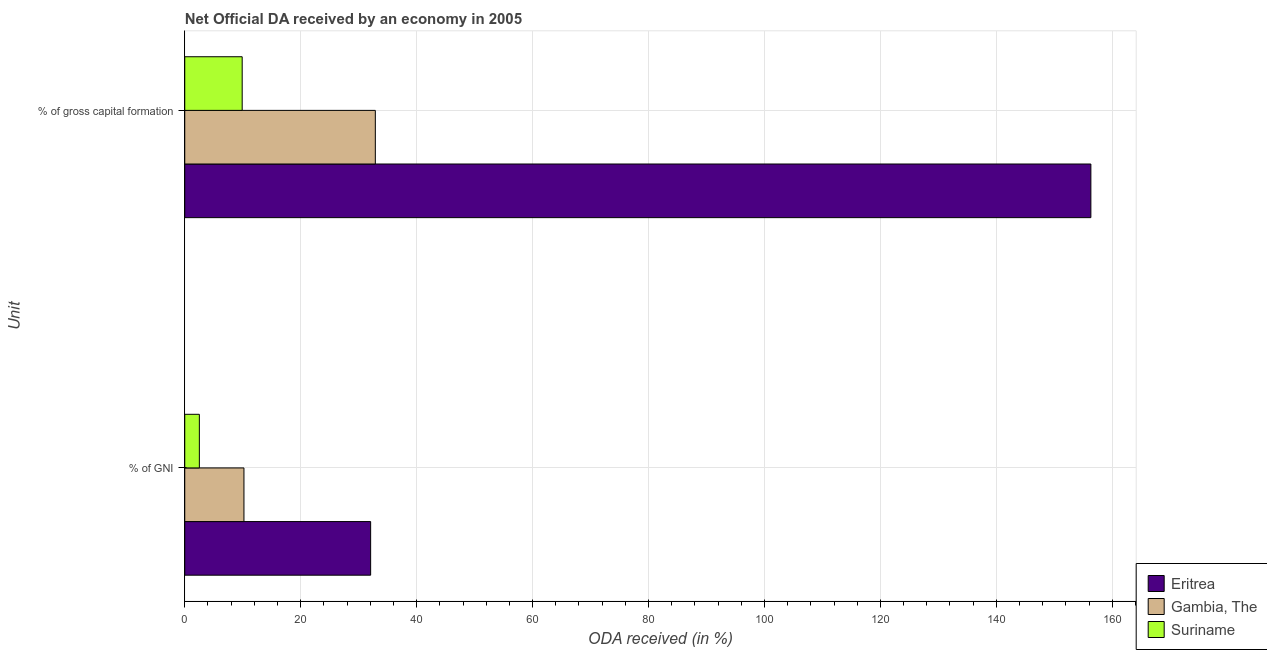How many different coloured bars are there?
Your answer should be compact. 3. How many groups of bars are there?
Ensure brevity in your answer.  2. Are the number of bars per tick equal to the number of legend labels?
Provide a succinct answer. Yes. Are the number of bars on each tick of the Y-axis equal?
Provide a succinct answer. Yes. How many bars are there on the 2nd tick from the top?
Provide a succinct answer. 3. What is the label of the 1st group of bars from the top?
Your answer should be very brief. % of gross capital formation. What is the oda received as percentage of gross capital formation in Eritrea?
Make the answer very short. 156.31. Across all countries, what is the maximum oda received as percentage of gni?
Make the answer very short. 32.07. Across all countries, what is the minimum oda received as percentage of gni?
Make the answer very short. 2.52. In which country was the oda received as percentage of gni maximum?
Provide a succinct answer. Eritrea. In which country was the oda received as percentage of gni minimum?
Your answer should be compact. Suriname. What is the total oda received as percentage of gross capital formation in the graph?
Offer a very short reply. 199.09. What is the difference between the oda received as percentage of gross capital formation in Suriname and that in Eritrea?
Make the answer very short. -146.4. What is the difference between the oda received as percentage of gni in Eritrea and the oda received as percentage of gross capital formation in Gambia, The?
Give a very brief answer. -0.81. What is the average oda received as percentage of gni per country?
Offer a terse response. 14.93. What is the difference between the oda received as percentage of gni and oda received as percentage of gross capital formation in Suriname?
Offer a very short reply. -7.39. What is the ratio of the oda received as percentage of gross capital formation in Suriname to that in Gambia, The?
Offer a terse response. 0.3. Is the oda received as percentage of gni in Gambia, The less than that in Eritrea?
Keep it short and to the point. Yes. In how many countries, is the oda received as percentage of gross capital formation greater than the average oda received as percentage of gross capital formation taken over all countries?
Your response must be concise. 1. What does the 2nd bar from the top in % of GNI represents?
Your response must be concise. Gambia, The. What does the 3rd bar from the bottom in % of GNI represents?
Make the answer very short. Suriname. Are all the bars in the graph horizontal?
Offer a very short reply. Yes. What is the difference between two consecutive major ticks on the X-axis?
Your answer should be compact. 20. Does the graph contain grids?
Provide a short and direct response. Yes. What is the title of the graph?
Offer a very short reply. Net Official DA received by an economy in 2005. Does "Turks and Caicos Islands" appear as one of the legend labels in the graph?
Provide a short and direct response. No. What is the label or title of the X-axis?
Offer a very short reply. ODA received (in %). What is the label or title of the Y-axis?
Provide a short and direct response. Unit. What is the ODA received (in %) in Eritrea in % of GNI?
Provide a short and direct response. 32.07. What is the ODA received (in %) in Gambia, The in % of GNI?
Provide a succinct answer. 10.21. What is the ODA received (in %) of Suriname in % of GNI?
Your answer should be compact. 2.52. What is the ODA received (in %) in Eritrea in % of gross capital formation?
Your answer should be compact. 156.31. What is the ODA received (in %) in Gambia, The in % of gross capital formation?
Keep it short and to the point. 32.87. What is the ODA received (in %) in Suriname in % of gross capital formation?
Give a very brief answer. 9.91. Across all Unit, what is the maximum ODA received (in %) of Eritrea?
Offer a very short reply. 156.31. Across all Unit, what is the maximum ODA received (in %) of Gambia, The?
Offer a very short reply. 32.87. Across all Unit, what is the maximum ODA received (in %) in Suriname?
Make the answer very short. 9.91. Across all Unit, what is the minimum ODA received (in %) in Eritrea?
Your answer should be compact. 32.07. Across all Unit, what is the minimum ODA received (in %) in Gambia, The?
Ensure brevity in your answer.  10.21. Across all Unit, what is the minimum ODA received (in %) of Suriname?
Provide a succinct answer. 2.52. What is the total ODA received (in %) in Eritrea in the graph?
Offer a terse response. 188.38. What is the total ODA received (in %) of Gambia, The in the graph?
Give a very brief answer. 43.09. What is the total ODA received (in %) of Suriname in the graph?
Your answer should be very brief. 12.43. What is the difference between the ODA received (in %) in Eritrea in % of GNI and that in % of gross capital formation?
Offer a very short reply. -124.24. What is the difference between the ODA received (in %) of Gambia, The in % of GNI and that in % of gross capital formation?
Keep it short and to the point. -22.66. What is the difference between the ODA received (in %) in Suriname in % of GNI and that in % of gross capital formation?
Your response must be concise. -7.39. What is the difference between the ODA received (in %) in Eritrea in % of GNI and the ODA received (in %) in Gambia, The in % of gross capital formation?
Provide a short and direct response. -0.81. What is the difference between the ODA received (in %) in Eritrea in % of GNI and the ODA received (in %) in Suriname in % of gross capital formation?
Provide a succinct answer. 22.16. What is the difference between the ODA received (in %) in Gambia, The in % of GNI and the ODA received (in %) in Suriname in % of gross capital formation?
Offer a terse response. 0.31. What is the average ODA received (in %) in Eritrea per Unit?
Your response must be concise. 94.19. What is the average ODA received (in %) in Gambia, The per Unit?
Give a very brief answer. 21.54. What is the average ODA received (in %) in Suriname per Unit?
Provide a short and direct response. 6.21. What is the difference between the ODA received (in %) of Eritrea and ODA received (in %) of Gambia, The in % of GNI?
Make the answer very short. 21.85. What is the difference between the ODA received (in %) in Eritrea and ODA received (in %) in Suriname in % of GNI?
Offer a very short reply. 29.55. What is the difference between the ODA received (in %) in Gambia, The and ODA received (in %) in Suriname in % of GNI?
Ensure brevity in your answer.  7.69. What is the difference between the ODA received (in %) in Eritrea and ODA received (in %) in Gambia, The in % of gross capital formation?
Your response must be concise. 123.44. What is the difference between the ODA received (in %) of Eritrea and ODA received (in %) of Suriname in % of gross capital formation?
Provide a short and direct response. 146.4. What is the difference between the ODA received (in %) of Gambia, The and ODA received (in %) of Suriname in % of gross capital formation?
Offer a terse response. 22.97. What is the ratio of the ODA received (in %) in Eritrea in % of GNI to that in % of gross capital formation?
Ensure brevity in your answer.  0.21. What is the ratio of the ODA received (in %) in Gambia, The in % of GNI to that in % of gross capital formation?
Provide a short and direct response. 0.31. What is the ratio of the ODA received (in %) of Suriname in % of GNI to that in % of gross capital formation?
Your answer should be very brief. 0.25. What is the difference between the highest and the second highest ODA received (in %) in Eritrea?
Offer a very short reply. 124.24. What is the difference between the highest and the second highest ODA received (in %) of Gambia, The?
Give a very brief answer. 22.66. What is the difference between the highest and the second highest ODA received (in %) of Suriname?
Provide a succinct answer. 7.39. What is the difference between the highest and the lowest ODA received (in %) in Eritrea?
Offer a terse response. 124.24. What is the difference between the highest and the lowest ODA received (in %) in Gambia, The?
Your answer should be compact. 22.66. What is the difference between the highest and the lowest ODA received (in %) in Suriname?
Keep it short and to the point. 7.39. 